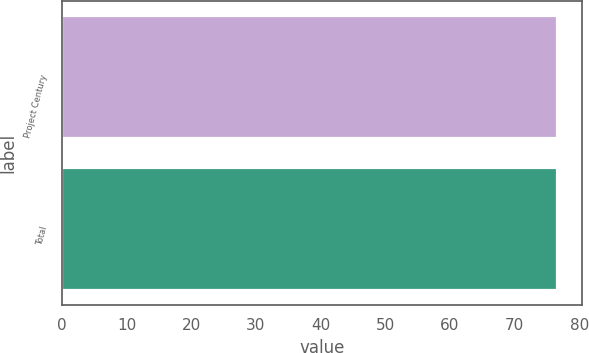Convert chart. <chart><loc_0><loc_0><loc_500><loc_500><bar_chart><fcel>Project Century<fcel>Total<nl><fcel>76.5<fcel>76.6<nl></chart> 